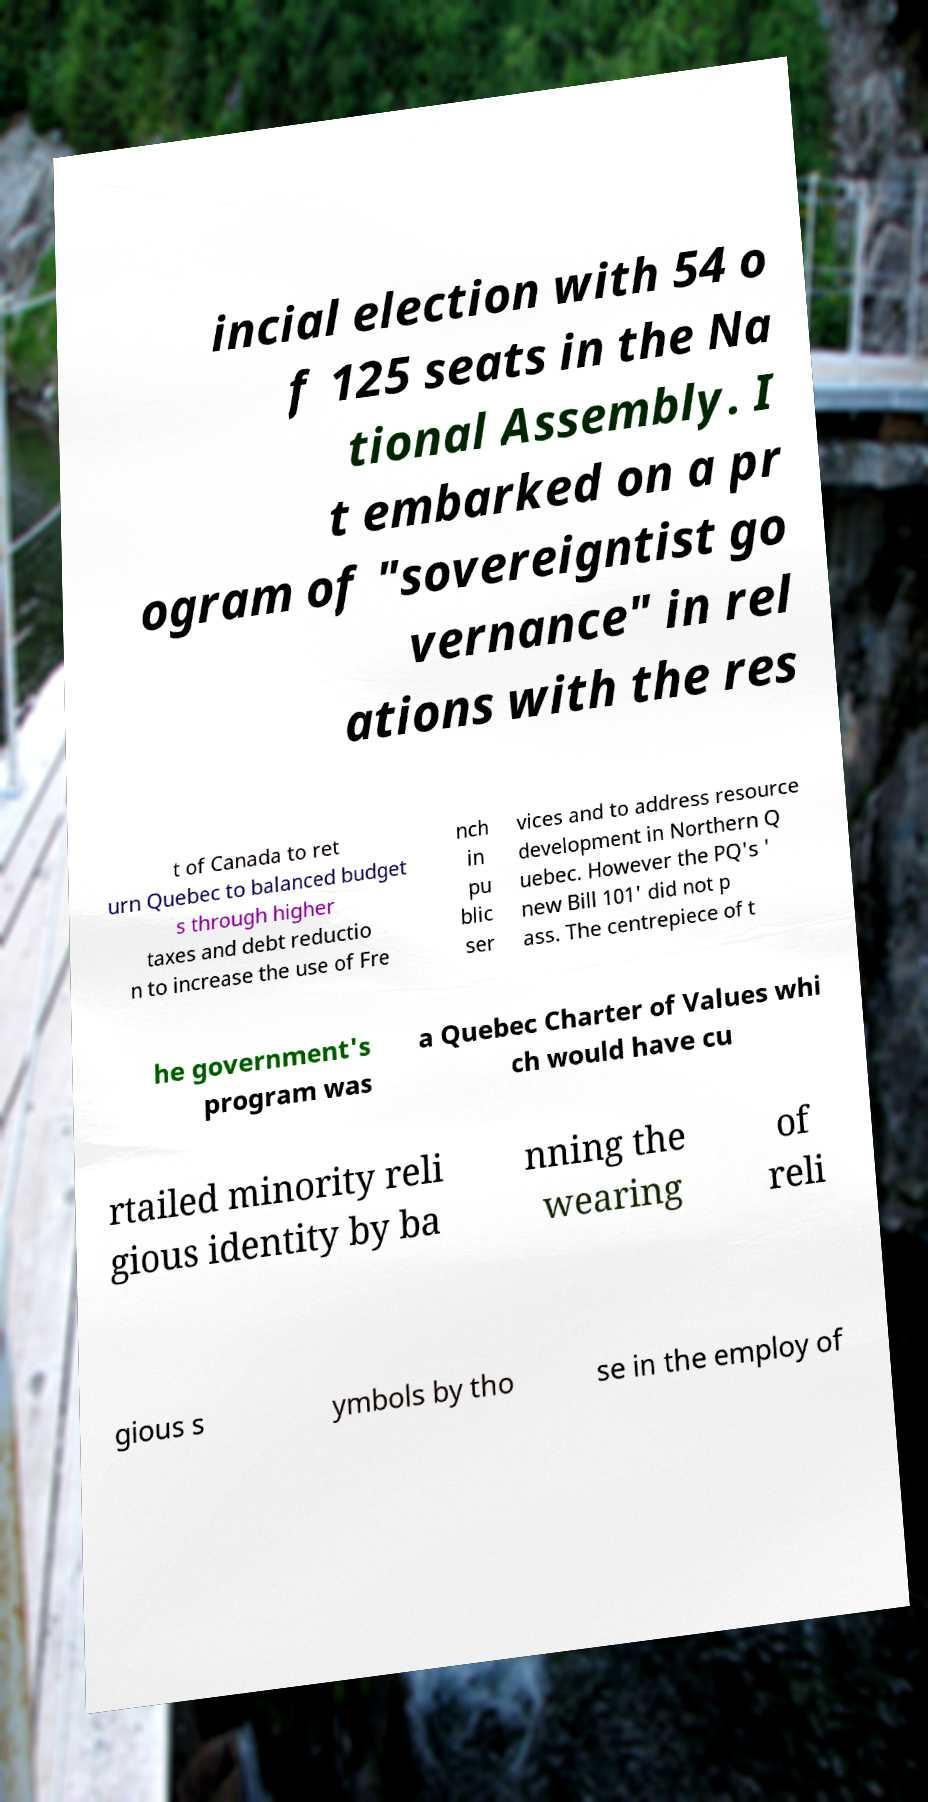Could you assist in decoding the text presented in this image and type it out clearly? incial election with 54 o f 125 seats in the Na tional Assembly. I t embarked on a pr ogram of "sovereigntist go vernance" in rel ations with the res t of Canada to ret urn Quebec to balanced budget s through higher taxes and debt reductio n to increase the use of Fre nch in pu blic ser vices and to address resource development in Northern Q uebec. However the PQ's ' new Bill 101' did not p ass. The centrepiece of t he government's program was a Quebec Charter of Values whi ch would have cu rtailed minority reli gious identity by ba nning the wearing of reli gious s ymbols by tho se in the employ of 